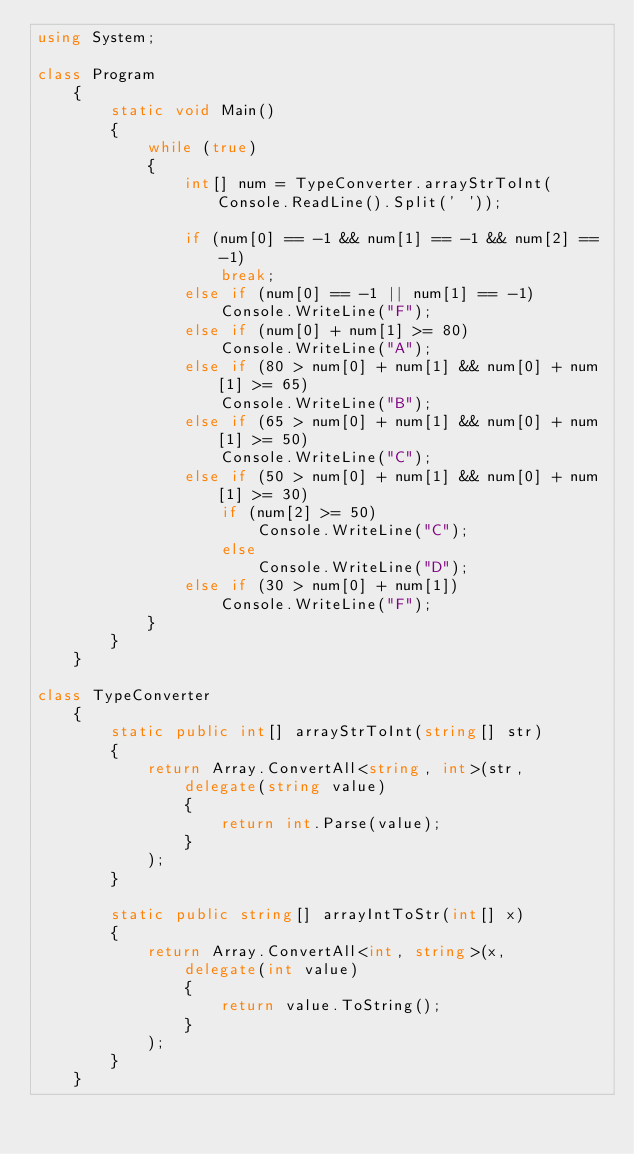Convert code to text. <code><loc_0><loc_0><loc_500><loc_500><_C#_>using System;

class Program
    {
        static void Main()
        {
            while (true)
            {
                int[] num = TypeConverter.arrayStrToInt(Console.ReadLine().Split(' '));

                if (num[0] == -1 && num[1] == -1 && num[2] == -1)
                    break;
                else if (num[0] == -1 || num[1] == -1)
                    Console.WriteLine("F");
                else if (num[0] + num[1] >= 80)
                    Console.WriteLine("A");
                else if (80 > num[0] + num[1] && num[0] + num[1] >= 65)
                    Console.WriteLine("B");
                else if (65 > num[0] + num[1] && num[0] + num[1] >= 50)
                    Console.WriteLine("C");
                else if (50 > num[0] + num[1] && num[0] + num[1] >= 30)
                    if (num[2] >= 50)
                        Console.WriteLine("C");
                    else
                        Console.WriteLine("D");
                else if (30 > num[0] + num[1])
                    Console.WriteLine("F");
            }
        }
    }

class TypeConverter
    {
        static public int[] arrayStrToInt(string[] str)
        {
            return Array.ConvertAll<string, int>(str,
                delegate(string value)
                {
                    return int.Parse(value);
                }
            );
        }

        static public string[] arrayIntToStr(int[] x)
        {
            return Array.ConvertAll<int, string>(x,
                delegate(int value)
                {
                    return value.ToString();
                }
            );
        }
    }</code> 